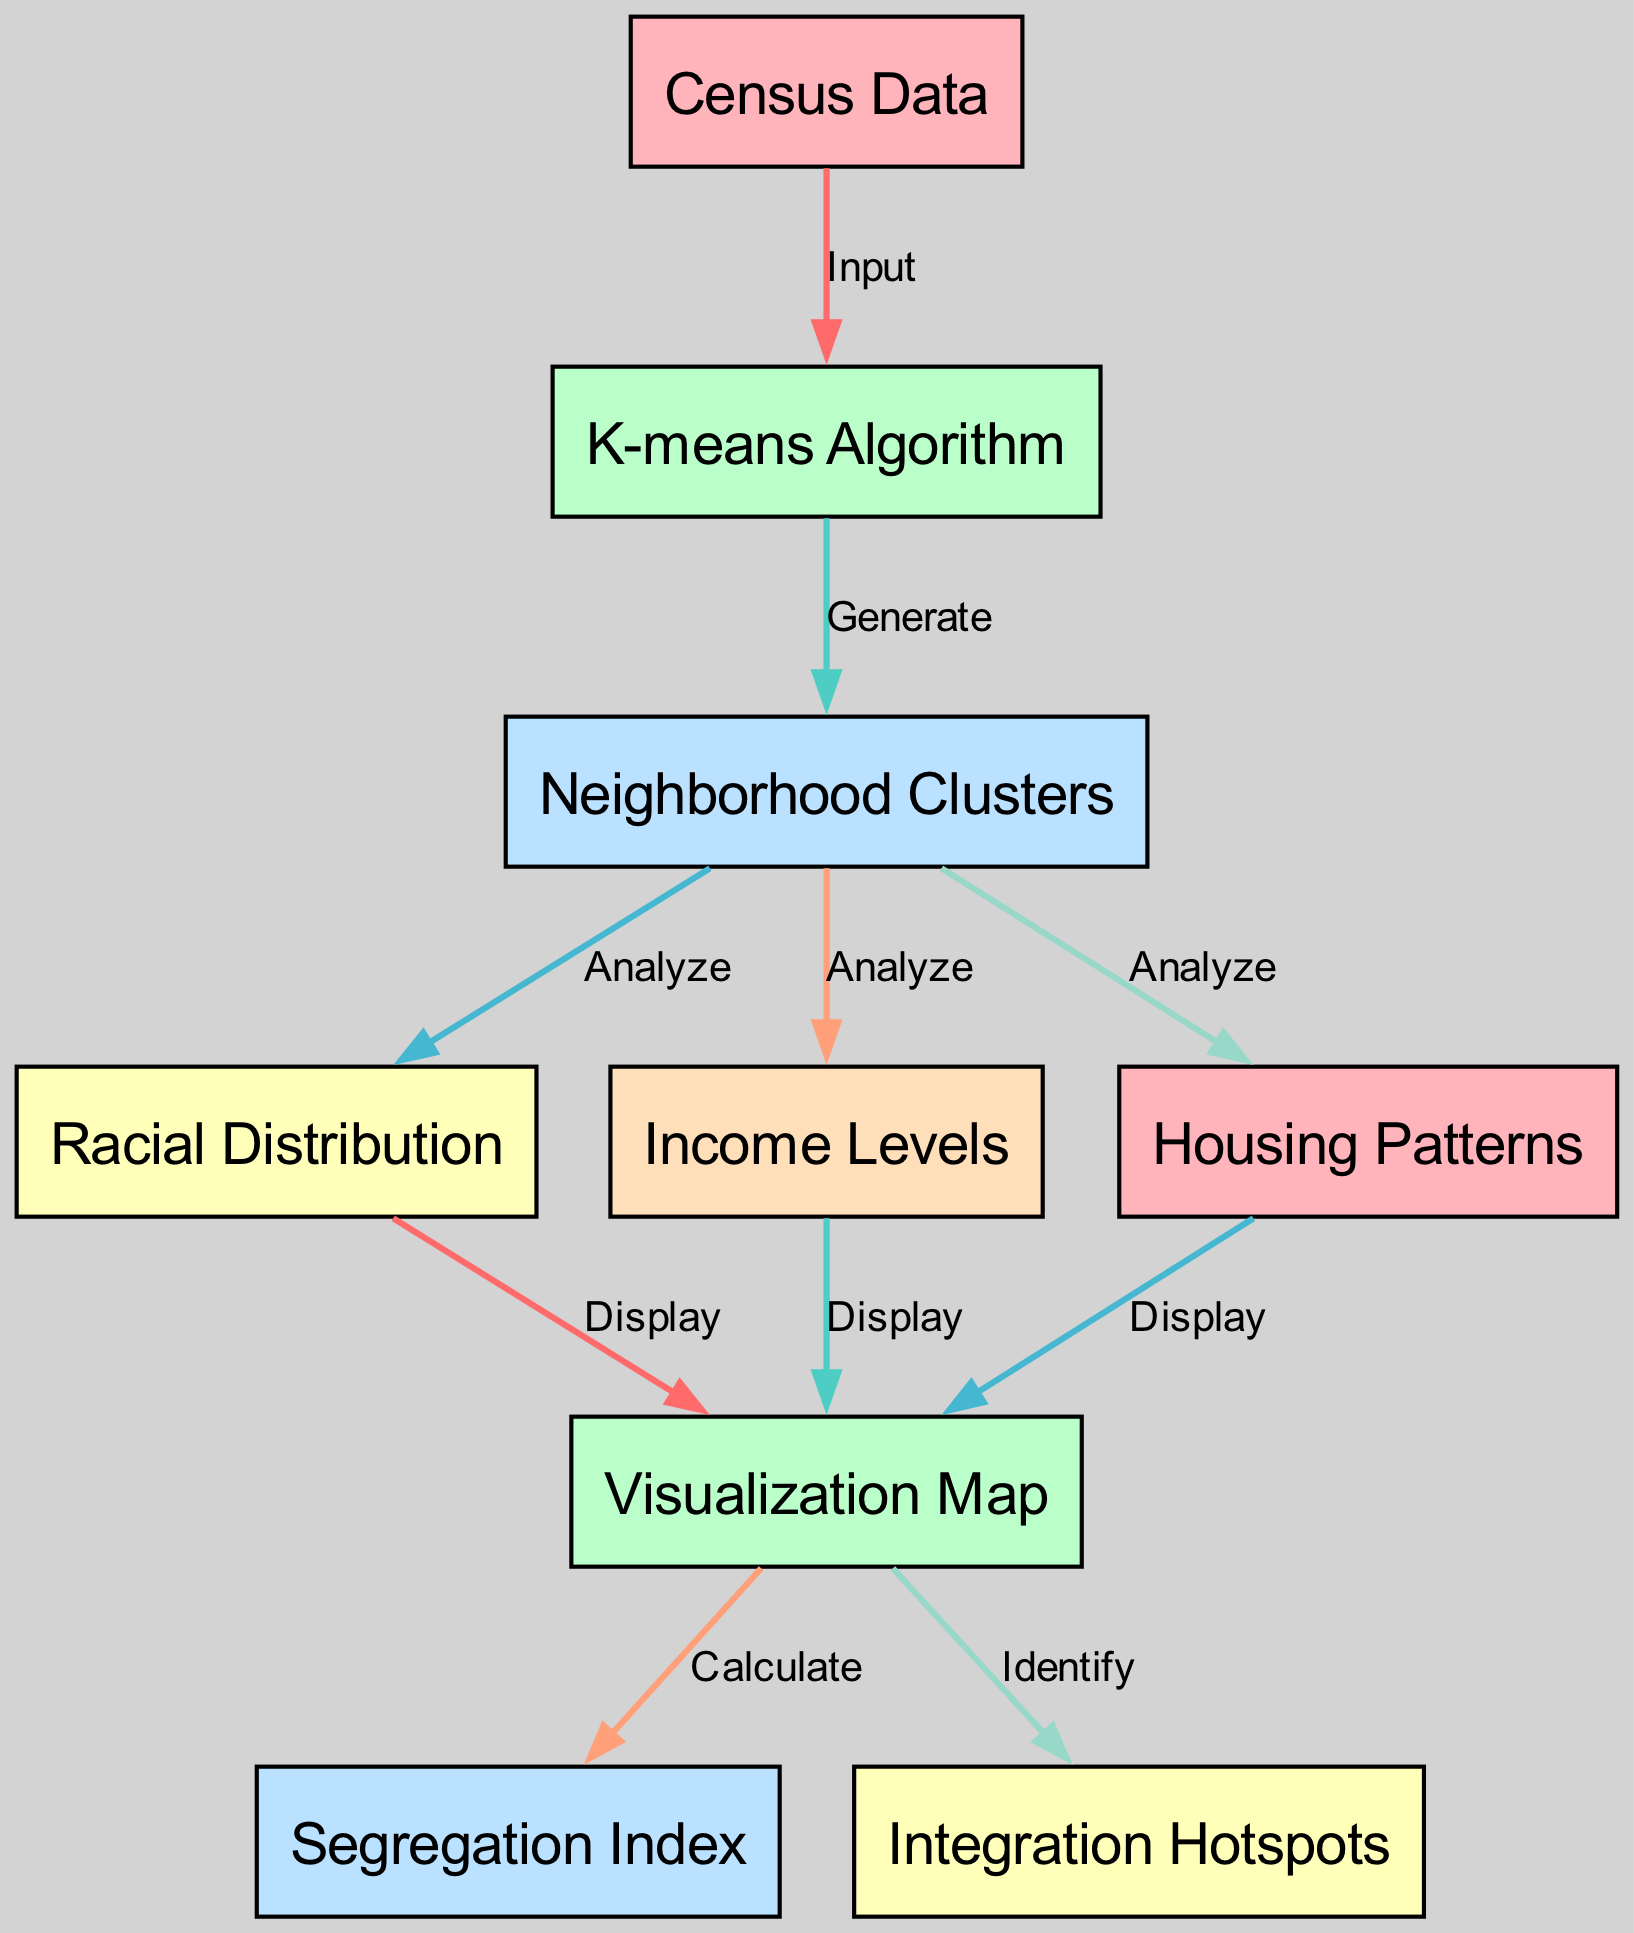What is the starting input for the diagram? The diagram indicates that the starting input for the process is "Census Data," which is the first node in the flow.
Answer: Census Data How many edges are there in the diagram? Counting the number of connections (edges) between nodes, there are a total of 10 edges illustrated in the diagram.
Answer: 10 What is the purpose of the K-means Algorithm in the diagram? The K-means Algorithm is used to generate "Neighborhood Clusters" based on the input from "Census Data," marking it as a crucial step in the process.
Answer: Generate Which node is used to calculate the Segregation Index? The "Visualization Map" node directly connects to the "Segregation Index" node indicating that it is where the calculation occurs.
Answer: Visualization Map How many nodes are analyzed from the Neighborhood Clusters? Three nodes—"Racial Distribution," "Income Levels," and "Housing Patterns"—are analyzed following the generation of "Neighborhood Clusters."
Answer: Three What node identifies Integration Hotspots? The "Visualization Map" node is responsible for identifying "Integration Hotspots," showing its role in highlighting areas of integration.
Answer: Visualization Map Describe the relationship between the "Neighborhood Clusters" and "Racial Distribution." The relationship is that "Neighborhood Clusters" is analyzed to provide insights into the "Racial Distribution," indicating a direct analytical flow.
Answer: Analyze In the diagram, which node comes after the K-means Algorithm node? Following the K-means Algorithm node, the next node is "Neighborhood Clusters," which represents the output of the clustering process.
Answer: Neighborhood Clusters What type of indexing is displayed in the diagram? The "Segregation Index" node represents a specific type of indexing relevant to the findings from the demographic analysis in the visualization.
Answer: Segregation Index 